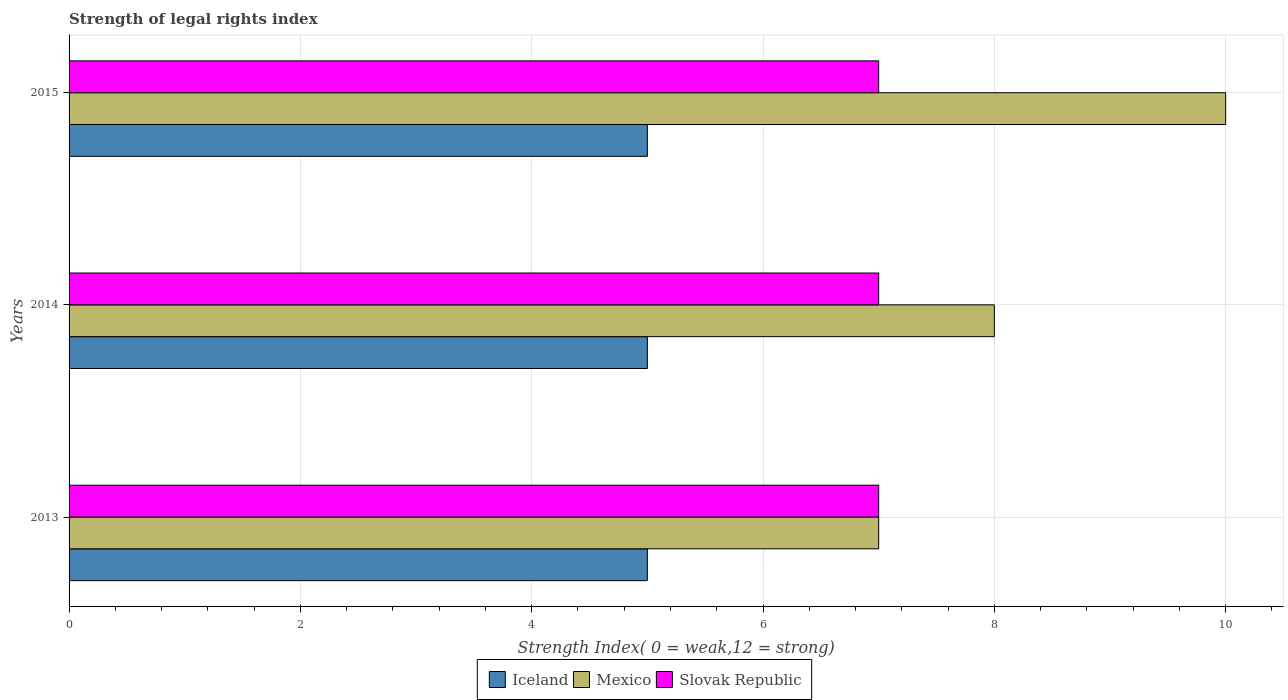How many different coloured bars are there?
Your response must be concise. 3. How many groups of bars are there?
Your response must be concise. 3. Are the number of bars per tick equal to the number of legend labels?
Your answer should be very brief. Yes. How many bars are there on the 3rd tick from the top?
Offer a very short reply. 3. How many bars are there on the 2nd tick from the bottom?
Give a very brief answer. 3. What is the label of the 1st group of bars from the top?
Make the answer very short. 2015. In how many cases, is the number of bars for a given year not equal to the number of legend labels?
Offer a terse response. 0. What is the strength index in Iceland in 2013?
Provide a succinct answer. 5. Across all years, what is the maximum strength index in Mexico?
Offer a terse response. 10. Across all years, what is the minimum strength index in Slovak Republic?
Make the answer very short. 7. In which year was the strength index in Iceland minimum?
Provide a short and direct response. 2013. What is the total strength index in Slovak Republic in the graph?
Offer a terse response. 21. What is the difference between the strength index in Slovak Republic in 2014 and the strength index in Mexico in 2013?
Your answer should be very brief. 0. In the year 2014, what is the difference between the strength index in Mexico and strength index in Slovak Republic?
Your answer should be compact. 1. In how many years, is the strength index in Slovak Republic greater than 7.6 ?
Provide a short and direct response. 0. Is the difference between the strength index in Mexico in 2014 and 2015 greater than the difference between the strength index in Slovak Republic in 2014 and 2015?
Provide a short and direct response. No. What is the difference between the highest and the lowest strength index in Mexico?
Make the answer very short. 3. What does the 1st bar from the top in 2015 represents?
Your answer should be compact. Slovak Republic. What does the 3rd bar from the bottom in 2015 represents?
Offer a very short reply. Slovak Republic. How many bars are there?
Provide a succinct answer. 9. Are all the bars in the graph horizontal?
Your answer should be very brief. Yes. Are the values on the major ticks of X-axis written in scientific E-notation?
Make the answer very short. No. Does the graph contain any zero values?
Offer a terse response. No. What is the title of the graph?
Provide a succinct answer. Strength of legal rights index. Does "Georgia" appear as one of the legend labels in the graph?
Make the answer very short. No. What is the label or title of the X-axis?
Your answer should be compact. Strength Index( 0 = weak,12 = strong). What is the Strength Index( 0 = weak,12 = strong) of Iceland in 2013?
Keep it short and to the point. 5. What is the Strength Index( 0 = weak,12 = strong) in Mexico in 2013?
Offer a terse response. 7. What is the Strength Index( 0 = weak,12 = strong) in Mexico in 2014?
Offer a terse response. 8. What is the Strength Index( 0 = weak,12 = strong) in Slovak Republic in 2014?
Your response must be concise. 7. What is the Strength Index( 0 = weak,12 = strong) of Iceland in 2015?
Provide a succinct answer. 5. What is the Strength Index( 0 = weak,12 = strong) of Mexico in 2015?
Offer a terse response. 10. What is the Strength Index( 0 = weak,12 = strong) of Slovak Republic in 2015?
Offer a very short reply. 7. Across all years, what is the minimum Strength Index( 0 = weak,12 = strong) of Iceland?
Provide a succinct answer. 5. Across all years, what is the minimum Strength Index( 0 = weak,12 = strong) of Mexico?
Provide a short and direct response. 7. What is the difference between the Strength Index( 0 = weak,12 = strong) in Mexico in 2013 and that in 2014?
Your response must be concise. -1. What is the difference between the Strength Index( 0 = weak,12 = strong) of Slovak Republic in 2013 and that in 2014?
Provide a succinct answer. 0. What is the difference between the Strength Index( 0 = weak,12 = strong) of Slovak Republic in 2013 and that in 2015?
Offer a terse response. 0. What is the difference between the Strength Index( 0 = weak,12 = strong) of Mexico in 2014 and that in 2015?
Give a very brief answer. -2. What is the difference between the Strength Index( 0 = weak,12 = strong) of Iceland in 2013 and the Strength Index( 0 = weak,12 = strong) of Mexico in 2014?
Your answer should be very brief. -3. What is the difference between the Strength Index( 0 = weak,12 = strong) in Iceland in 2013 and the Strength Index( 0 = weak,12 = strong) in Slovak Republic in 2014?
Ensure brevity in your answer.  -2. What is the difference between the Strength Index( 0 = weak,12 = strong) in Mexico in 2013 and the Strength Index( 0 = weak,12 = strong) in Slovak Republic in 2014?
Offer a terse response. 0. What is the difference between the Strength Index( 0 = weak,12 = strong) of Mexico in 2013 and the Strength Index( 0 = weak,12 = strong) of Slovak Republic in 2015?
Make the answer very short. 0. What is the difference between the Strength Index( 0 = weak,12 = strong) in Iceland in 2014 and the Strength Index( 0 = weak,12 = strong) in Mexico in 2015?
Keep it short and to the point. -5. What is the difference between the Strength Index( 0 = weak,12 = strong) in Mexico in 2014 and the Strength Index( 0 = weak,12 = strong) in Slovak Republic in 2015?
Give a very brief answer. 1. What is the average Strength Index( 0 = weak,12 = strong) of Mexico per year?
Make the answer very short. 8.33. In the year 2013, what is the difference between the Strength Index( 0 = weak,12 = strong) in Iceland and Strength Index( 0 = weak,12 = strong) in Slovak Republic?
Give a very brief answer. -2. In the year 2013, what is the difference between the Strength Index( 0 = weak,12 = strong) in Mexico and Strength Index( 0 = weak,12 = strong) in Slovak Republic?
Your answer should be very brief. 0. In the year 2014, what is the difference between the Strength Index( 0 = weak,12 = strong) of Mexico and Strength Index( 0 = weak,12 = strong) of Slovak Republic?
Give a very brief answer. 1. In the year 2015, what is the difference between the Strength Index( 0 = weak,12 = strong) in Iceland and Strength Index( 0 = weak,12 = strong) in Mexico?
Keep it short and to the point. -5. In the year 2015, what is the difference between the Strength Index( 0 = weak,12 = strong) of Mexico and Strength Index( 0 = weak,12 = strong) of Slovak Republic?
Your response must be concise. 3. What is the ratio of the Strength Index( 0 = weak,12 = strong) of Slovak Republic in 2013 to that in 2015?
Offer a terse response. 1. What is the difference between the highest and the second highest Strength Index( 0 = weak,12 = strong) in Mexico?
Your answer should be compact. 2. What is the difference between the highest and the second highest Strength Index( 0 = weak,12 = strong) of Slovak Republic?
Offer a terse response. 0. 